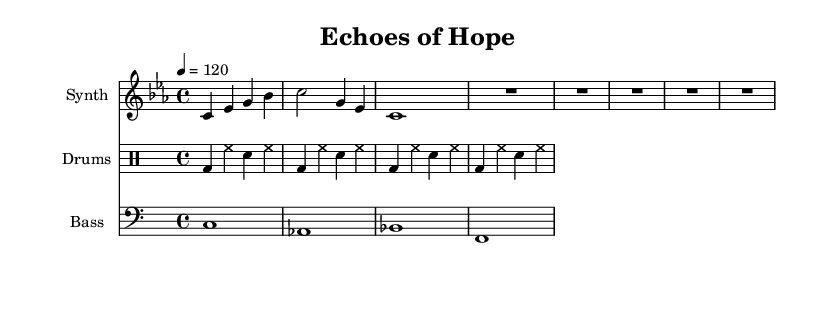What is the key signature of this music? The key signature is indicated at the beginning of the music, showing no sharps or flats, which defines the key as C minor.
Answer: C minor What is the time signature of this piece? The time signature is found at the beginning of the score, shown as 4/4, which means there are four beats in a measure and a quarter note receives one beat.
Answer: 4/4 What is the tempo marked in the sheet music? The tempo is indicated in the score and is set to 120 beats per minute, specifying the speed of the piece.
Answer: 120 How many measures are present in the synthesizer part? We count the measures in the synthesizer line, which are separated by vertical bars; there are a total of 5 measures.
Answer: 5 What type of ensemble does this score represent? The score consists of three distinct parts: synthesizer, drums, and bass, indicating it is for an electronic ensemble setup.
Answer: Electronic ensemble How does the bass line contribute to the overall mood of the piece? Analyzing the bass line, it uses sustained notes, providing a foundation that creates a deep, resonant undercurrent, typical of electronic music.
Answer: Deep, resonant 